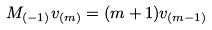Convert formula to latex. <formula><loc_0><loc_0><loc_500><loc_500>M _ { ( - 1 ) } v _ { ( m ) } = ( m + 1 ) v _ { ( m - 1 ) }</formula> 